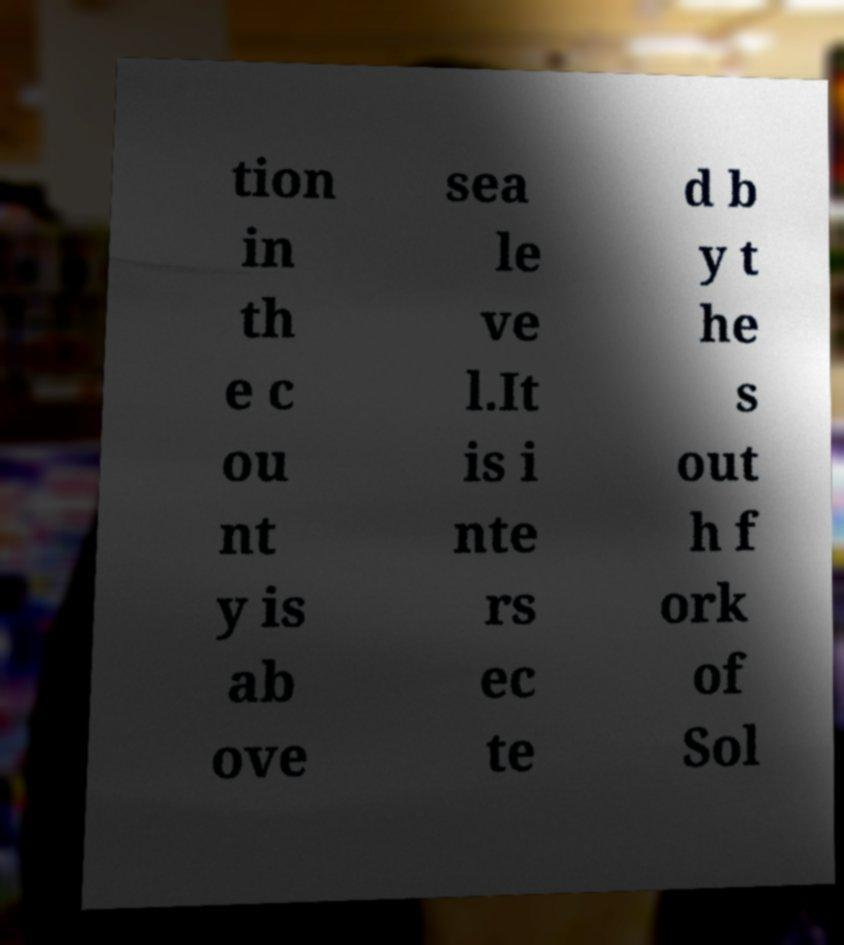What messages or text are displayed in this image? I need them in a readable, typed format. tion in th e c ou nt y is ab ove sea le ve l.It is i nte rs ec te d b y t he s out h f ork of Sol 